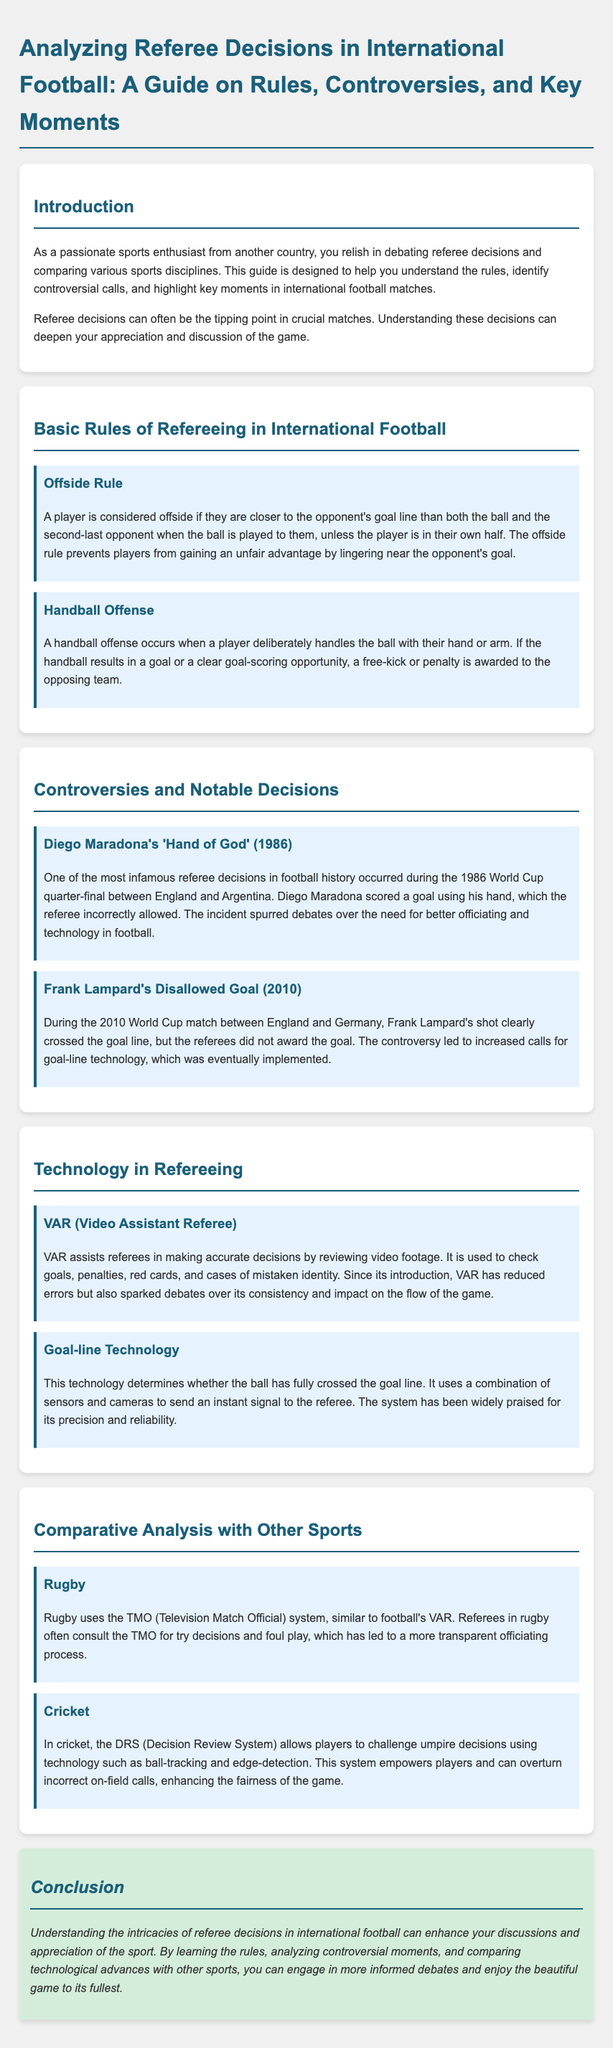What is the title of the guide? The title of the guide is located in the header section of the document.
Answer: Analyzing Referee Decisions in International Football: A Guide on Rules, Controversies, and Key Moments Which year did Diego Maradona's 'Hand of God' incident occur? The year of the incident is mentioned in the section discussing controversies and notable decisions.
Answer: 1986 What technology is used to determine if the ball has crossed the goal line? This technology is discussed in the section on goal-line technology.
Answer: Goal-line Technology What does VAR stand for? The abbreviation VAR is defined in the section on technology in refereeing.
Answer: Video Assistant Referee Which sport compares to football's VAR system with the TMO? The document includes a comparison with another sport that uses a similar system.
Answer: Rugby How many rules are mentioned in the basic rules section? The number of rules is based on the content presented in that section of the document.
Answer: 2 What was the main result of Frank Lampard's disallowed goal? The outcome is mentioned in relation to the resulting changes in technology use after the incident.
Answer: Increased calls for goal-line technology What is a key aspect of the Decision Review System in cricket? The key aspect is explained in the section comparing technologies used in different sports.
Answer: Players can challenge umpire decisions 